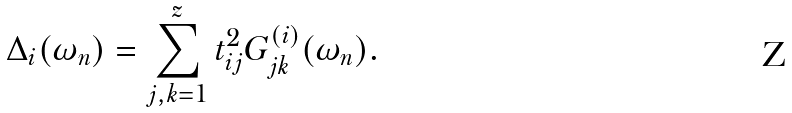Convert formula to latex. <formula><loc_0><loc_0><loc_500><loc_500>\Delta _ { i } ( \omega _ { n } ) = \sum _ { j , k = 1 } ^ { z } t _ { i j } ^ { 2 } G _ { j k } ^ { ( i ) } ( \omega _ { n } ) .</formula> 